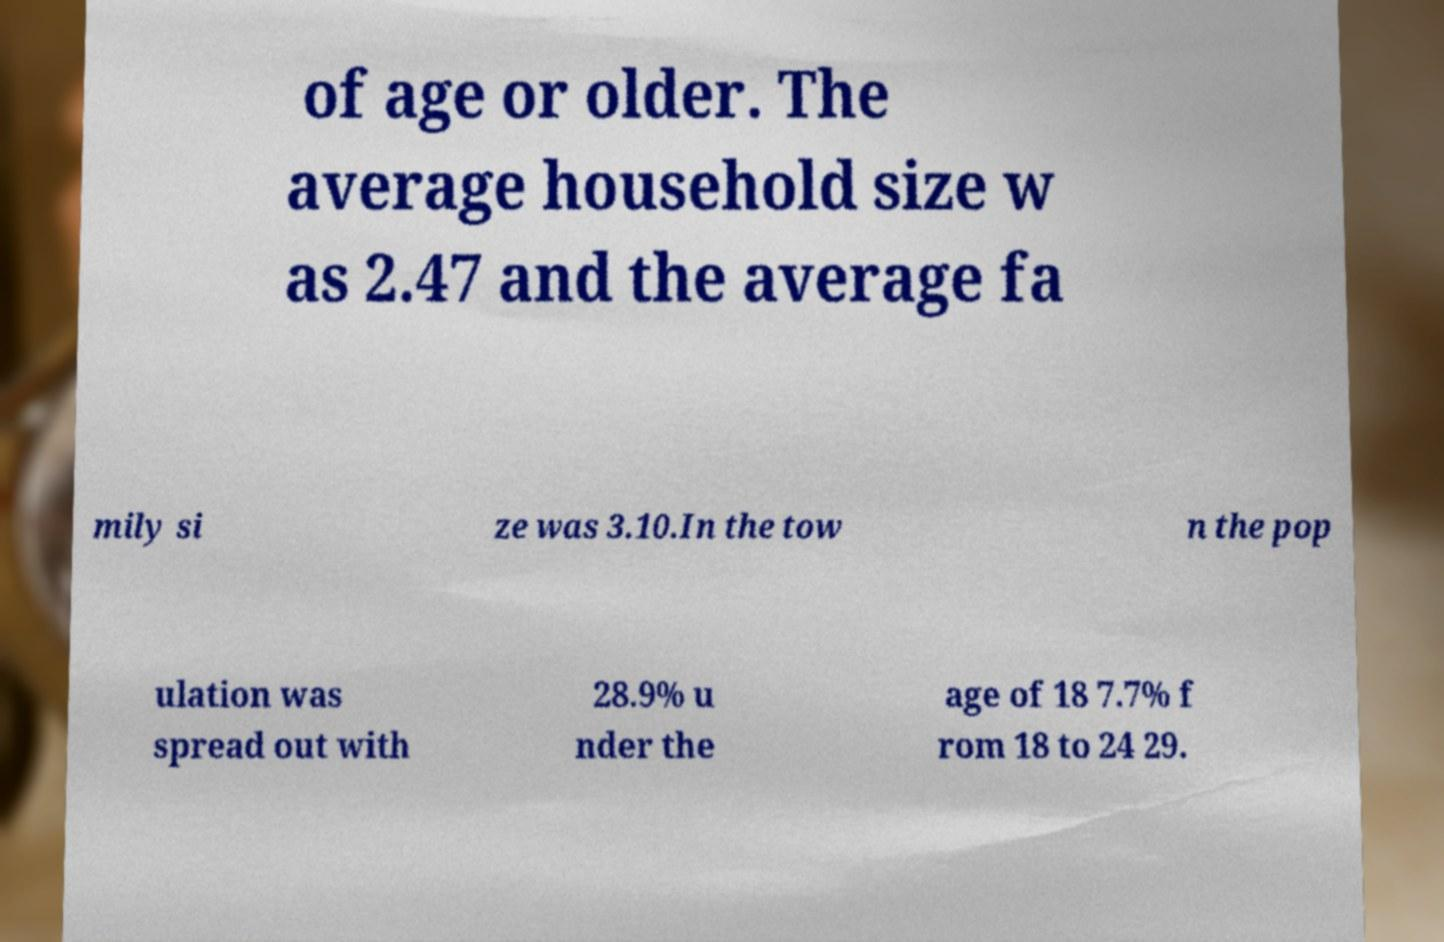There's text embedded in this image that I need extracted. Can you transcribe it verbatim? of age or older. The average household size w as 2.47 and the average fa mily si ze was 3.10.In the tow n the pop ulation was spread out with 28.9% u nder the age of 18 7.7% f rom 18 to 24 29. 